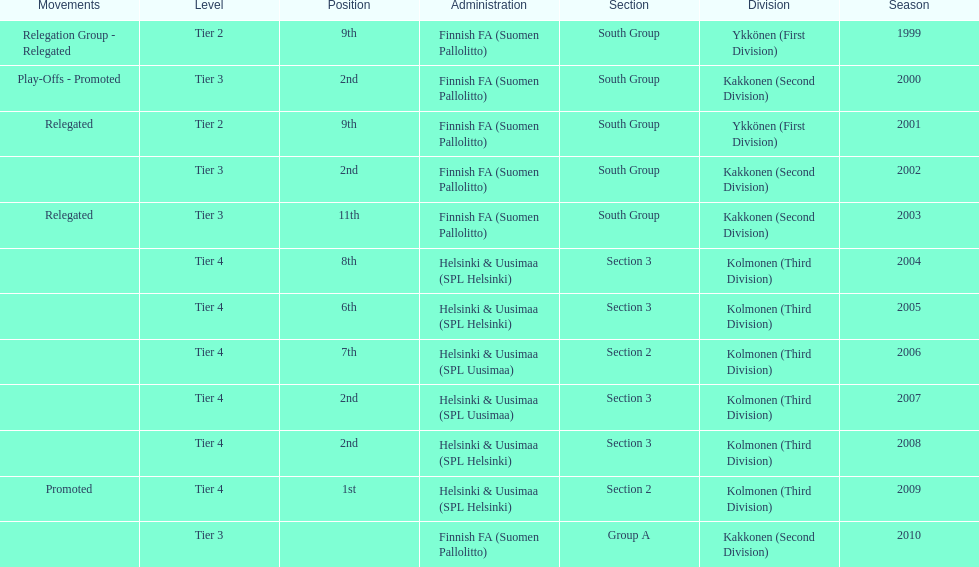What was the latest year they secured the 2nd position? 2008. 